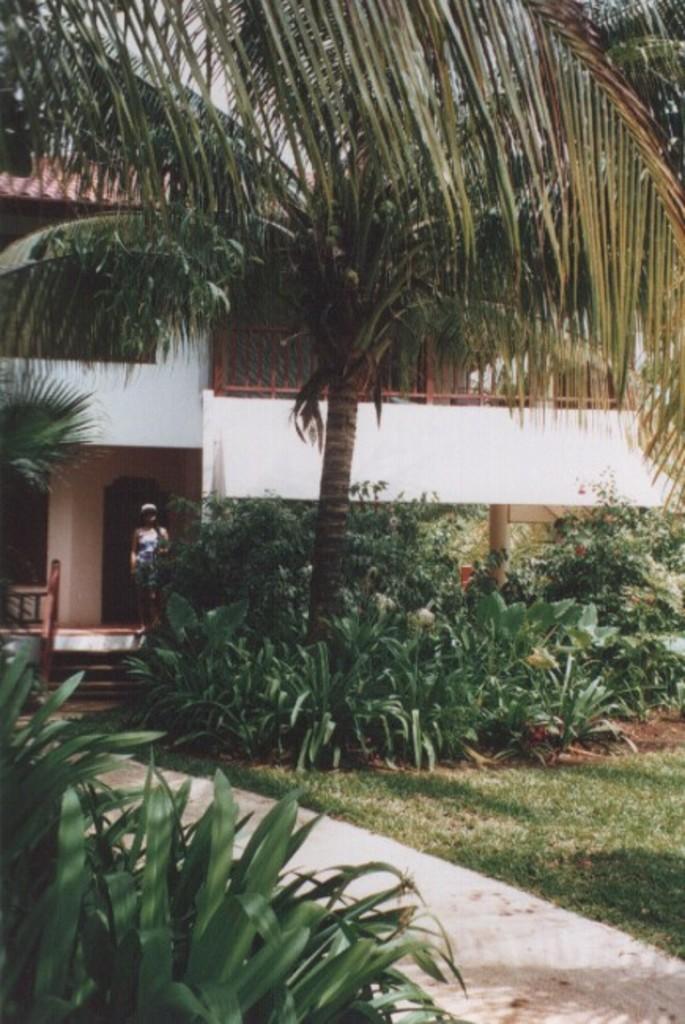How would you summarize this image in a sentence or two? In the image there is a path, around the path there is grass, plant and trees. Behind the trees there is a house and there is a woman standing in front of the house. 